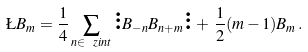Convert formula to latex. <formula><loc_0><loc_0><loc_500><loc_500>\L B _ { m } = \frac { 1 } { 4 } \sum _ { n \in \ z i n t } \vdots B _ { - n } B _ { n + m } \vdots \, + \, \frac { 1 } { 2 } ( m - 1 ) B _ { m } \, .</formula> 